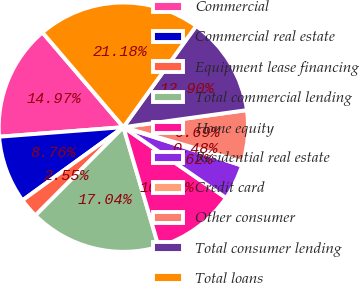Convert chart. <chart><loc_0><loc_0><loc_500><loc_500><pie_chart><fcel>Commercial<fcel>Commercial real estate<fcel>Equipment lease financing<fcel>Total commercial lending<fcel>Home equity<fcel>Residential real estate<fcel>Credit card<fcel>Other consumer<fcel>Total consumer lending<fcel>Total loans<nl><fcel>14.97%<fcel>8.76%<fcel>2.55%<fcel>17.04%<fcel>10.83%<fcel>4.62%<fcel>0.48%<fcel>6.69%<fcel>12.9%<fcel>21.18%<nl></chart> 